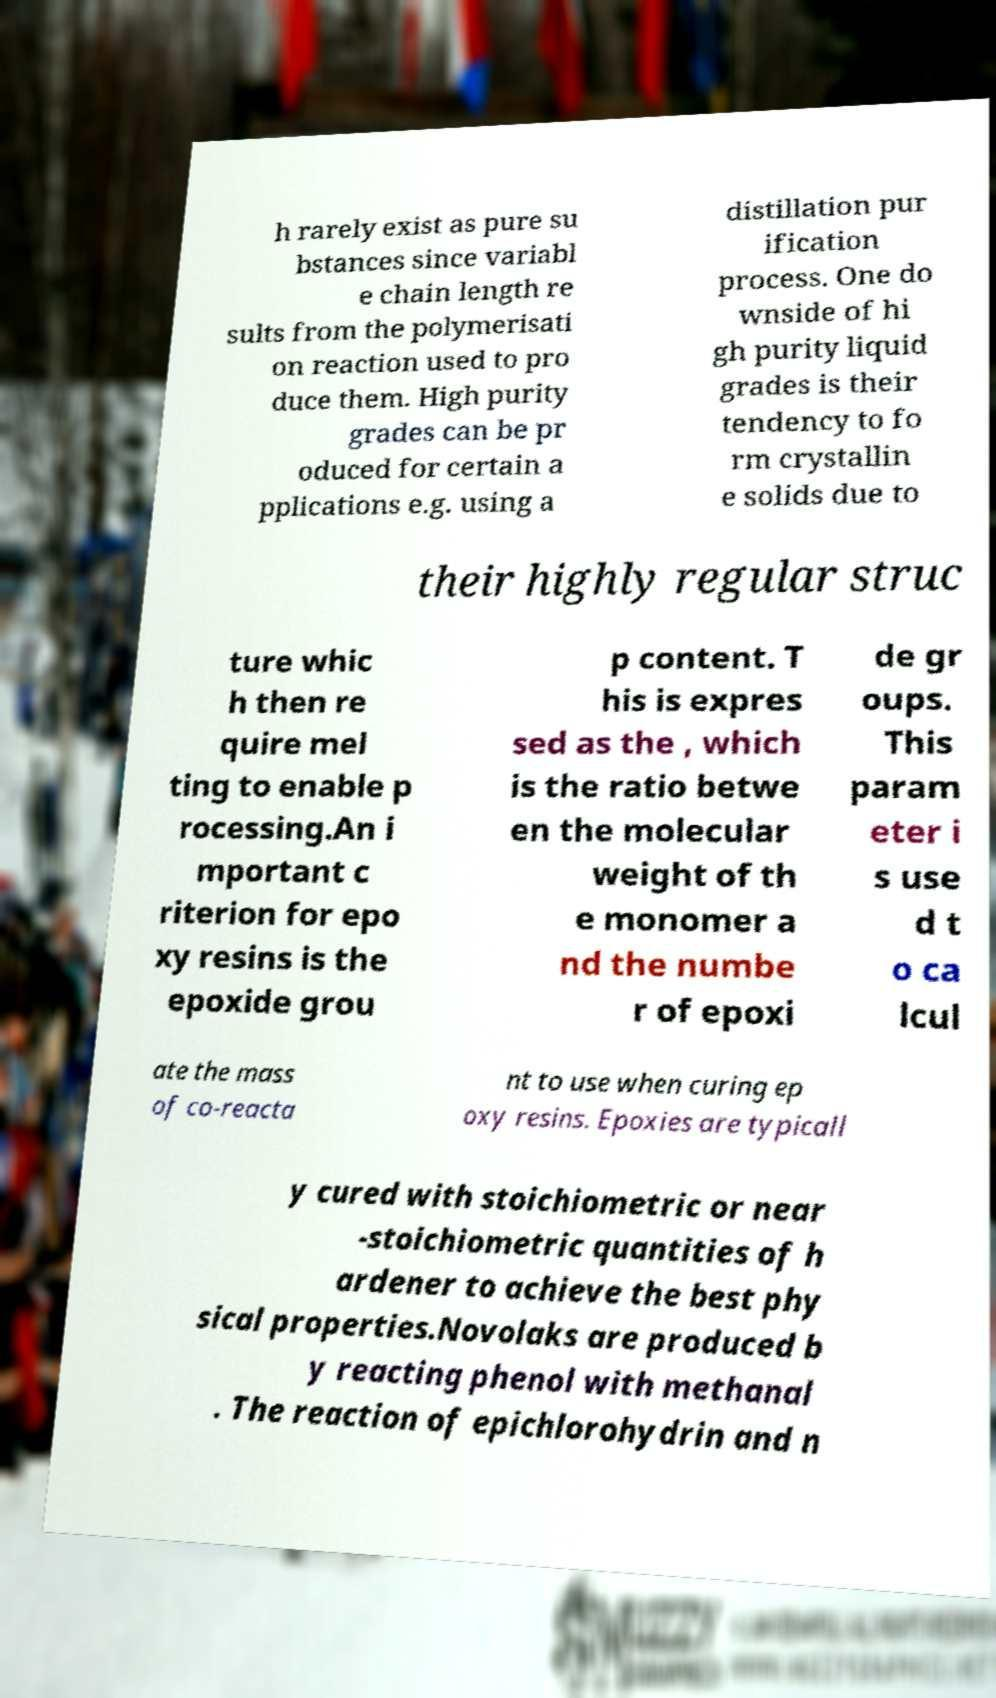Can you accurately transcribe the text from the provided image for me? h rarely exist as pure su bstances since variabl e chain length re sults from the polymerisati on reaction used to pro duce them. High purity grades can be pr oduced for certain a pplications e.g. using a distillation pur ification process. One do wnside of hi gh purity liquid grades is their tendency to fo rm crystallin e solids due to their highly regular struc ture whic h then re quire mel ting to enable p rocessing.An i mportant c riterion for epo xy resins is the epoxide grou p content. T his is expres sed as the , which is the ratio betwe en the molecular weight of th e monomer a nd the numbe r of epoxi de gr oups. This param eter i s use d t o ca lcul ate the mass of co-reacta nt to use when curing ep oxy resins. Epoxies are typicall y cured with stoichiometric or near -stoichiometric quantities of h ardener to achieve the best phy sical properties.Novolaks are produced b y reacting phenol with methanal . The reaction of epichlorohydrin and n 